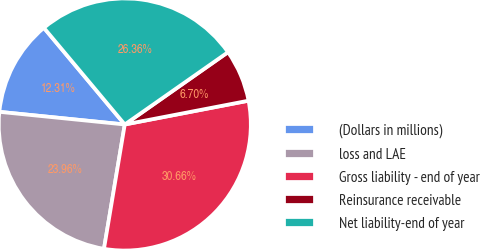<chart> <loc_0><loc_0><loc_500><loc_500><pie_chart><fcel>(Dollars in millions)<fcel>loss and LAE<fcel>Gross liability - end of year<fcel>Reinsurance receivable<fcel>Net liability-end of year<nl><fcel>12.31%<fcel>23.96%<fcel>30.66%<fcel>6.7%<fcel>26.36%<nl></chart> 